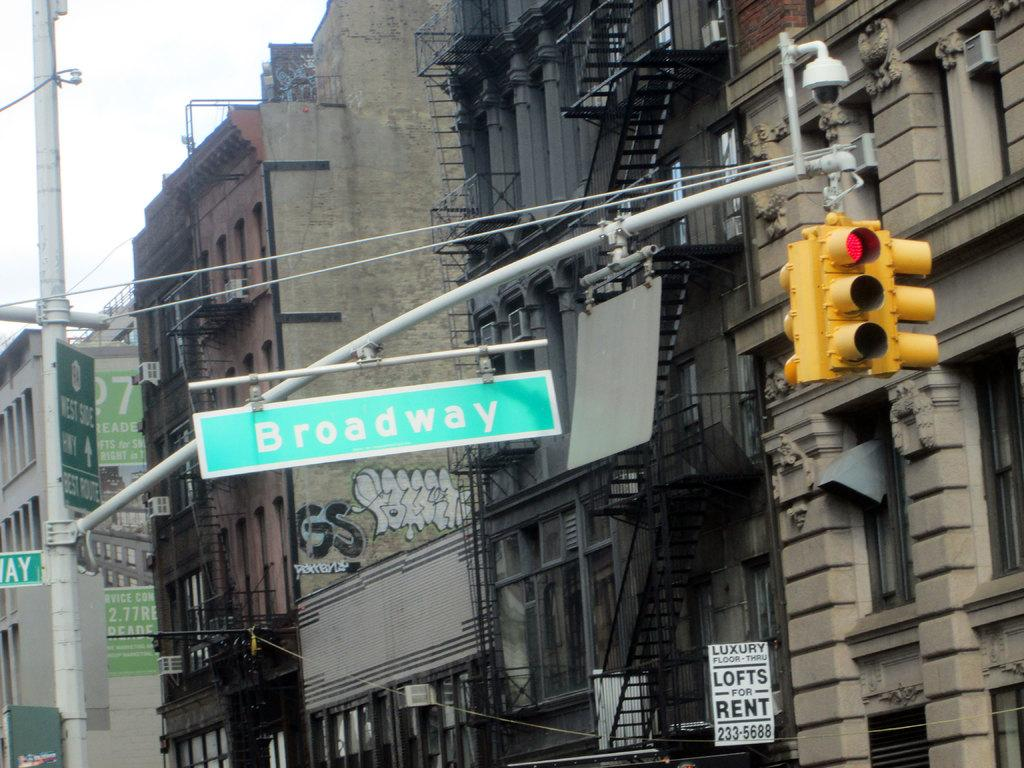<image>
Summarize the visual content of the image. A street named Broadway hanging up by some poles next to a stop light. 